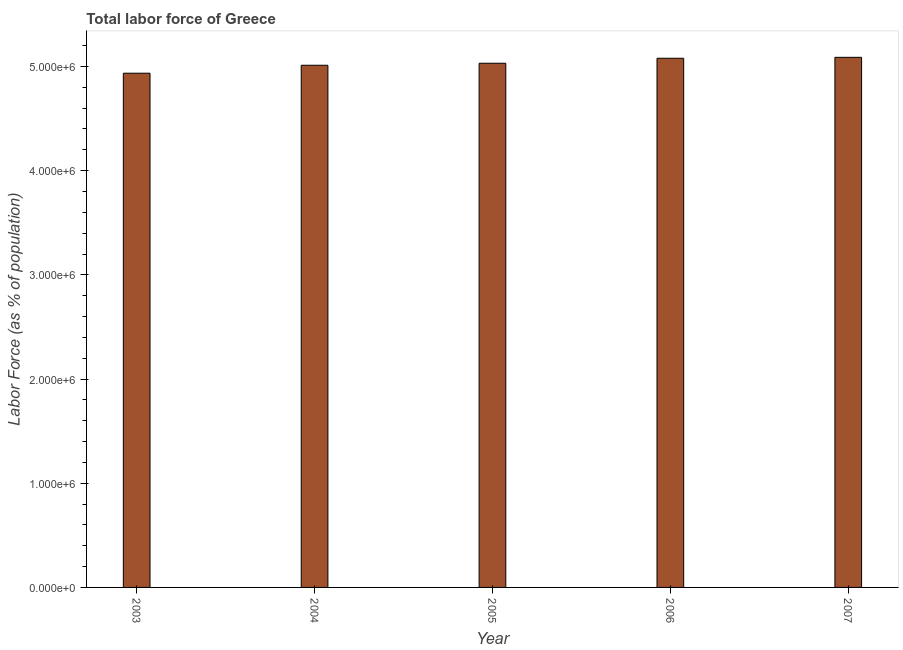Does the graph contain any zero values?
Provide a succinct answer. No. What is the title of the graph?
Provide a short and direct response. Total labor force of Greece. What is the label or title of the Y-axis?
Make the answer very short. Labor Force (as % of population). What is the total labor force in 2003?
Offer a very short reply. 4.94e+06. Across all years, what is the maximum total labor force?
Your answer should be compact. 5.09e+06. Across all years, what is the minimum total labor force?
Provide a short and direct response. 4.94e+06. In which year was the total labor force minimum?
Provide a succinct answer. 2003. What is the sum of the total labor force?
Your answer should be compact. 2.51e+07. What is the difference between the total labor force in 2005 and 2007?
Your answer should be compact. -5.67e+04. What is the average total labor force per year?
Your response must be concise. 5.03e+06. What is the median total labor force?
Keep it short and to the point. 5.03e+06. Do a majority of the years between 2007 and 2005 (inclusive) have total labor force greater than 2000000 %?
Offer a terse response. Yes. What is the difference between the highest and the second highest total labor force?
Your response must be concise. 8900. What is the difference between the highest and the lowest total labor force?
Offer a very short reply. 1.52e+05. How many bars are there?
Give a very brief answer. 5. Are all the bars in the graph horizontal?
Your response must be concise. No. How many years are there in the graph?
Give a very brief answer. 5. What is the Labor Force (as % of population) of 2003?
Ensure brevity in your answer.  4.94e+06. What is the Labor Force (as % of population) in 2004?
Keep it short and to the point. 5.01e+06. What is the Labor Force (as % of population) of 2005?
Your answer should be very brief. 5.03e+06. What is the Labor Force (as % of population) in 2006?
Your answer should be very brief. 5.08e+06. What is the Labor Force (as % of population) in 2007?
Your answer should be very brief. 5.09e+06. What is the difference between the Labor Force (as % of population) in 2003 and 2004?
Ensure brevity in your answer.  -7.63e+04. What is the difference between the Labor Force (as % of population) in 2003 and 2005?
Your response must be concise. -9.58e+04. What is the difference between the Labor Force (as % of population) in 2003 and 2006?
Provide a short and direct response. -1.44e+05. What is the difference between the Labor Force (as % of population) in 2003 and 2007?
Provide a short and direct response. -1.52e+05. What is the difference between the Labor Force (as % of population) in 2004 and 2005?
Keep it short and to the point. -1.94e+04. What is the difference between the Labor Force (as % of population) in 2004 and 2006?
Ensure brevity in your answer.  -6.72e+04. What is the difference between the Labor Force (as % of population) in 2004 and 2007?
Keep it short and to the point. -7.61e+04. What is the difference between the Labor Force (as % of population) in 2005 and 2006?
Give a very brief answer. -4.78e+04. What is the difference between the Labor Force (as % of population) in 2005 and 2007?
Your answer should be compact. -5.67e+04. What is the difference between the Labor Force (as % of population) in 2006 and 2007?
Your answer should be very brief. -8900. What is the ratio of the Labor Force (as % of population) in 2003 to that in 2004?
Your answer should be very brief. 0.98. What is the ratio of the Labor Force (as % of population) in 2004 to that in 2006?
Ensure brevity in your answer.  0.99. What is the ratio of the Labor Force (as % of population) in 2004 to that in 2007?
Provide a succinct answer. 0.98. What is the ratio of the Labor Force (as % of population) in 2005 to that in 2007?
Keep it short and to the point. 0.99. What is the ratio of the Labor Force (as % of population) in 2006 to that in 2007?
Give a very brief answer. 1. 